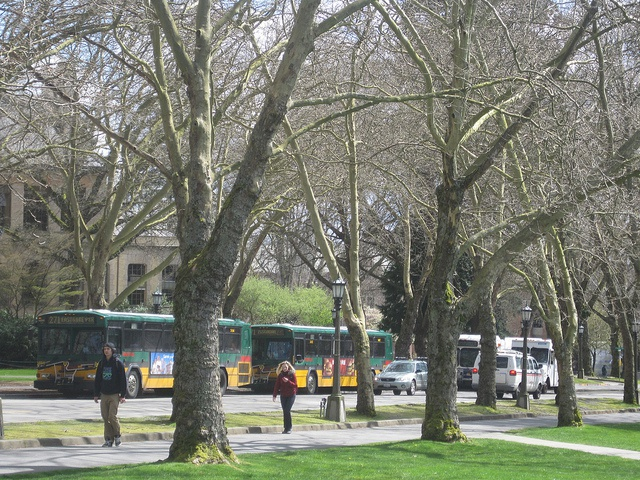Describe the objects in this image and their specific colors. I can see bus in gray, black, purple, and darkgray tones, bus in gray, black, purple, and teal tones, people in gray, black, and darkgray tones, truck in gray, darkgray, lightgray, and black tones, and car in gray, darkgray, and lightgray tones in this image. 